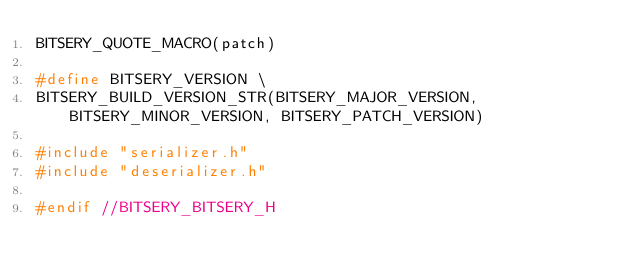Convert code to text. <code><loc_0><loc_0><loc_500><loc_500><_C_>BITSERY_QUOTE_MACRO(patch)

#define BITSERY_VERSION \
BITSERY_BUILD_VERSION_STR(BITSERY_MAJOR_VERSION, BITSERY_MINOR_VERSION, BITSERY_PATCH_VERSION)

#include "serializer.h"
#include "deserializer.h"

#endif //BITSERY_BITSERY_H
</code> 